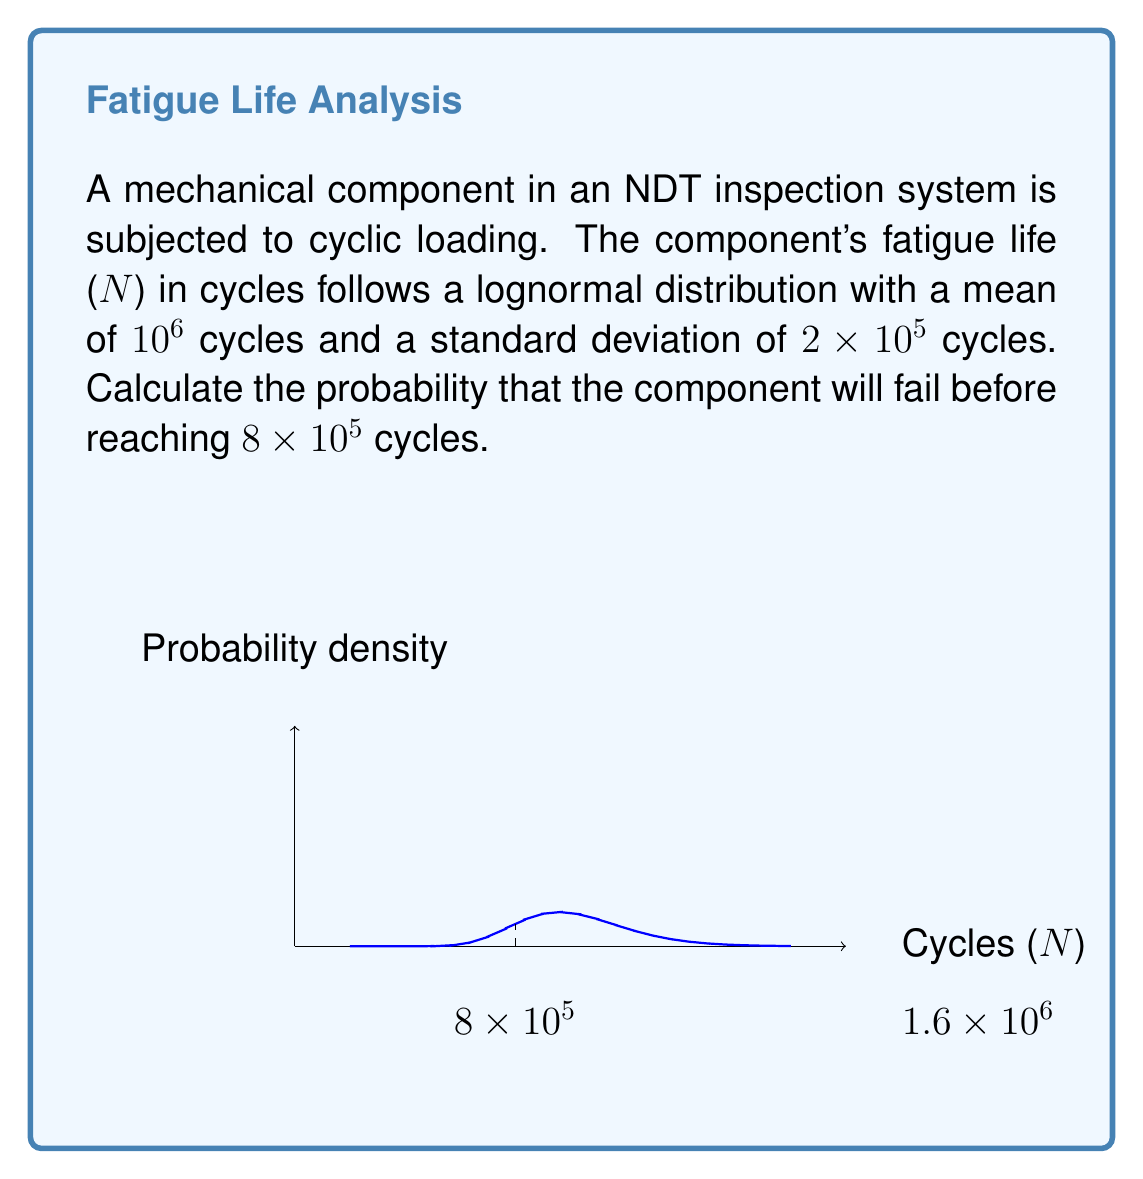Can you answer this question? To solve this problem, we'll follow these steps:

1) For a lognormal distribution, we need to find the parameters μ and σ of the associated normal distribution.

2) Given:
   Mean (m) = 10^6
   Standard deviation (s) = 2 × 10^5

3) For a lognormal distribution:
   $$\mu = \ln(m) - \frac{1}{2}\ln(1 + (\frac{s}{m})^2)$$
   $$\sigma^2 = \ln(1 + (\frac{s}{m})^2)$$

4) Calculating σ:
   $$\sigma^2 = \ln(1 + (\frac{2 \times 10^5}{10^6})^2) = \ln(1.04) = 0.0392$$
   $$\sigma = \sqrt{0.0392} = 0.1980$$

5) Calculating μ:
   $$\mu = \ln(10^6) - \frac{1}{2}(0.0392) = 13.8155$$

6) To find the probability of failure before 8 × 10^5 cycles, we need to calculate:
   $$P(N < 8 \times 10^5) = P(\ln(N) < \ln(8 \times 10^5))$$

7) Standardizing:
   $$Z = \frac{\ln(8 \times 10^5) - \mu}{\sigma} = \frac{13.5924 - 13.8155}{0.1980} = -1.1269$$

8) Using a standard normal distribution table or calculator:
   $$P(Z < -1.1269) = 0.1299$$

Therefore, the probability that the component will fail before reaching 8 × 10^5 cycles is approximately 0.1299 or 12.99%.
Answer: 0.1299 